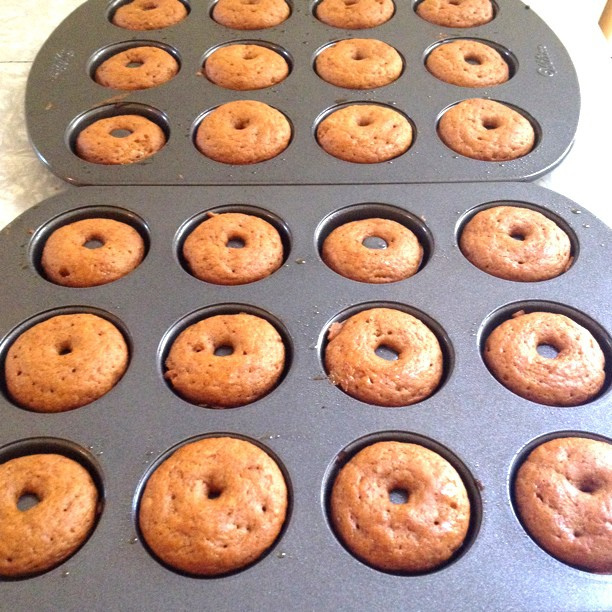How many apple iphones are there? There are no Apple iPhones in the image. The picture shows a baking tray with freshly baked donuts. 